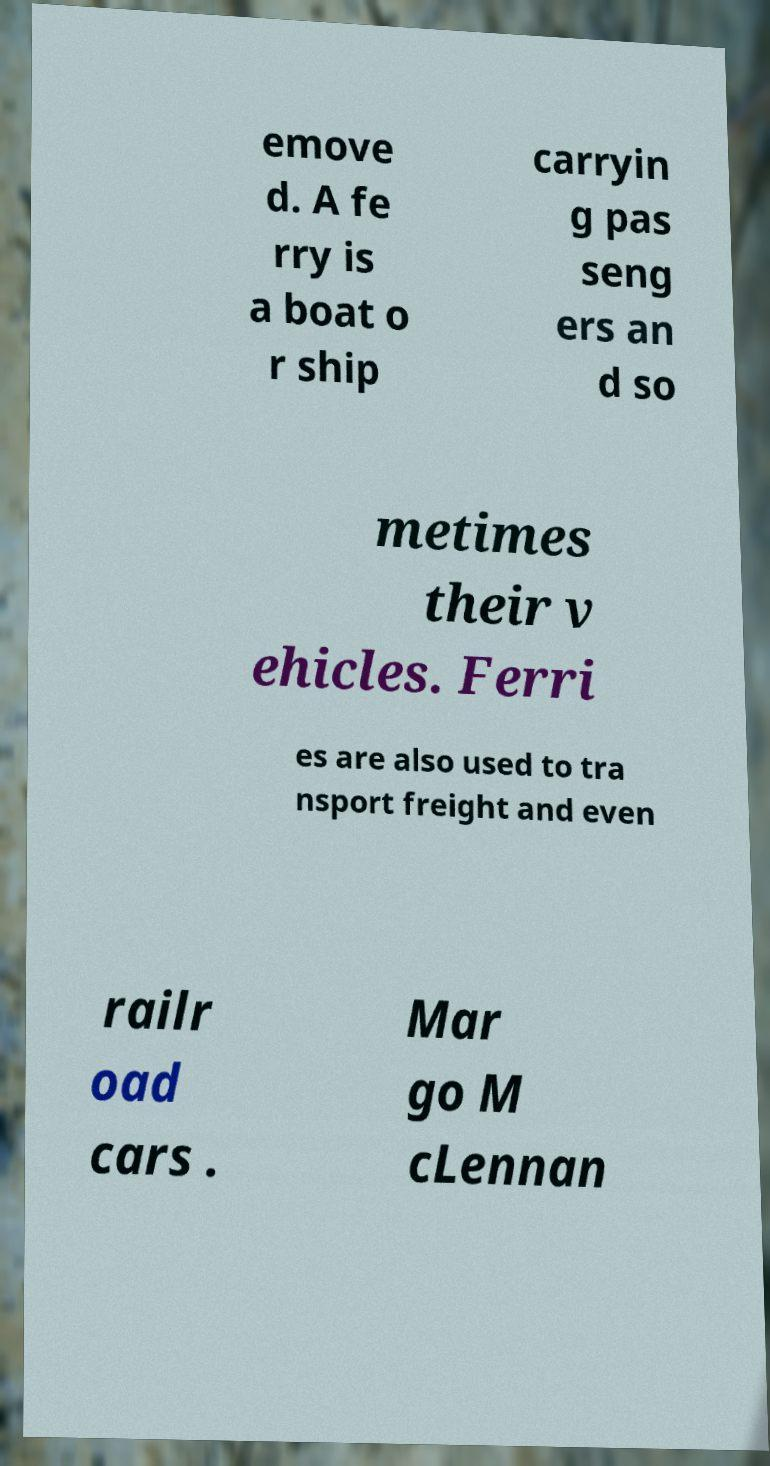Please read and relay the text visible in this image. What does it say? emove d. A fe rry is a boat o r ship carryin g pas seng ers an d so metimes their v ehicles. Ferri es are also used to tra nsport freight and even railr oad cars . Mar go M cLennan 